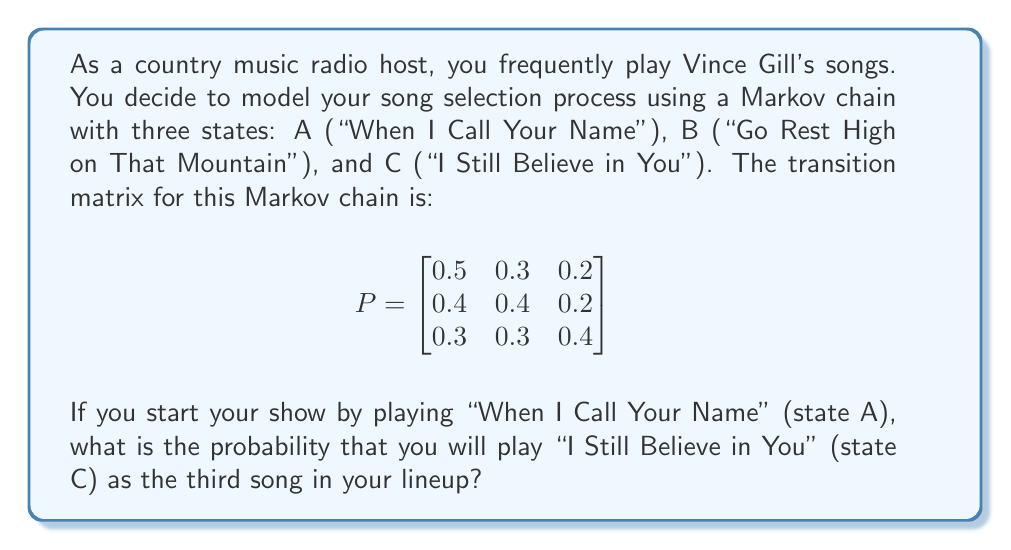Teach me how to tackle this problem. To solve this problem, we need to use the properties of Markov chains and matrix multiplication. Let's break it down step-by-step:

1) We start in state A and want to know the probability of being in state C after two transitions.

2) This can be calculated by raising the transition matrix P to the power of 2 and looking at the entry in the first row, third column.

3) Let's calculate $P^2$:

   $$P^2 = P \times P = \begin{bmatrix}
   0.5 & 0.3 & 0.2 \\
   0.4 & 0.4 & 0.2 \\
   0.3 & 0.3 & 0.4
   \end{bmatrix} \times \begin{bmatrix}
   0.5 & 0.3 & 0.2 \\
   0.4 & 0.4 & 0.2 \\
   0.3 & 0.3 & 0.4
   \end{bmatrix}$$

4) Performing the matrix multiplication:

   $$P^2 = \begin{bmatrix}
   (0.5)(0.5) + (0.3)(0.4) + (0.2)(0.3) & \cdots & (0.5)(0.2) + (0.3)(0.2) + (0.2)(0.4) \\
   \vdots & \ddots & \vdots \\
   (0.3)(0.5) + (0.3)(0.4) + (0.4)(0.3) & \cdots & (0.3)(0.2) + (0.3)(0.2) + (0.4)(0.4)
   \end{bmatrix}$$

5) Calculating the first row, third column entry (which is what we need):

   $(0.5)(0.2) + (0.3)(0.2) + (0.2)(0.4) = 0.1 + 0.06 + 0.08 = 0.24$

6) Therefore, the probability of playing "I Still Believe in You" as the third song, given that you started with "When I Call Your Name", is 0.24 or 24%.
Answer: 0.24 